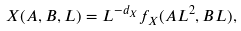Convert formula to latex. <formula><loc_0><loc_0><loc_500><loc_500>X ( A , B , L ) = L ^ { - d _ { X } } f _ { X } ( A L ^ { 2 } , B L ) ,</formula> 